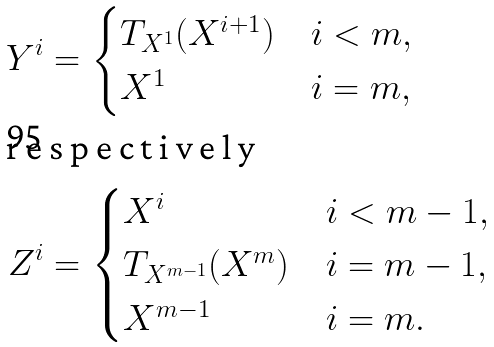<formula> <loc_0><loc_0><loc_500><loc_500>Y ^ { i } & = \begin{cases} T _ { X ^ { 1 } } ( X ^ { i + 1 } ) & i < m , \\ X ^ { 1 } & i = m , \end{cases} \\ \intertext { r e s p e c t i v e l y } Z ^ { i } & = \begin{cases} X ^ { i } & i < m - 1 , \\ T _ { X ^ { m - 1 } } ( X ^ { m } ) & i = m - 1 , \\ X ^ { m - 1 } & i = m . \end{cases}</formula> 